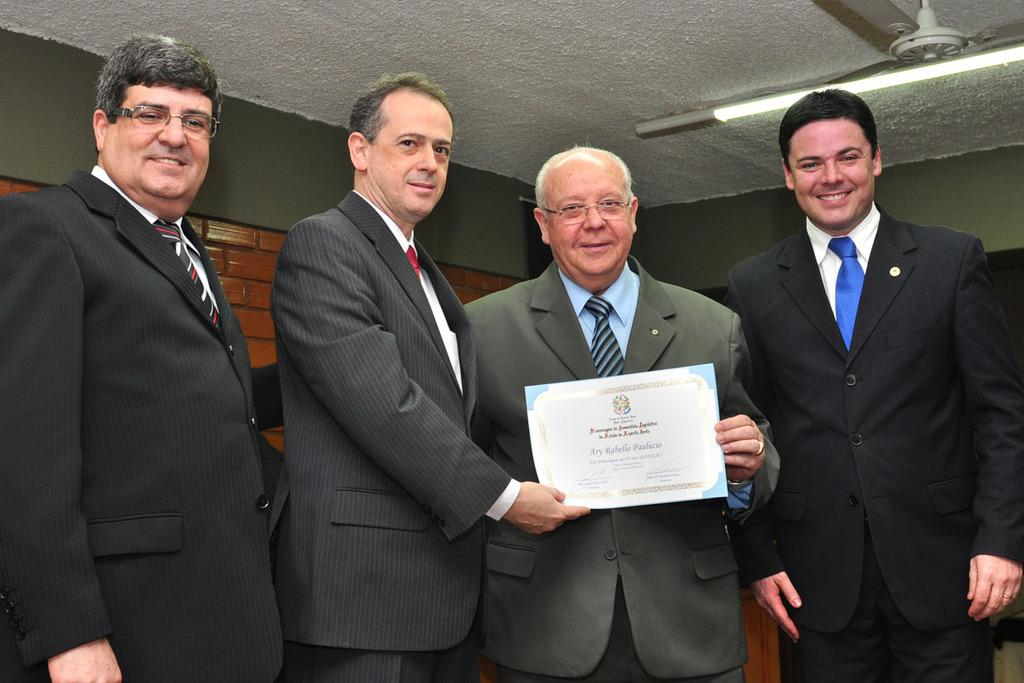How many people are in the foreground of the image? There are four men in the foreground of the image. What are the men doing in the image? The men are posing for a photo. What are two of the men holding in the image? Two of the men are holding a certificate. What can be seen in the background of the image? There is a wall in the background of the image. What type of straw is being used for comfort in the image? There is no straw present in the image, and therefore no such use can be observed. 